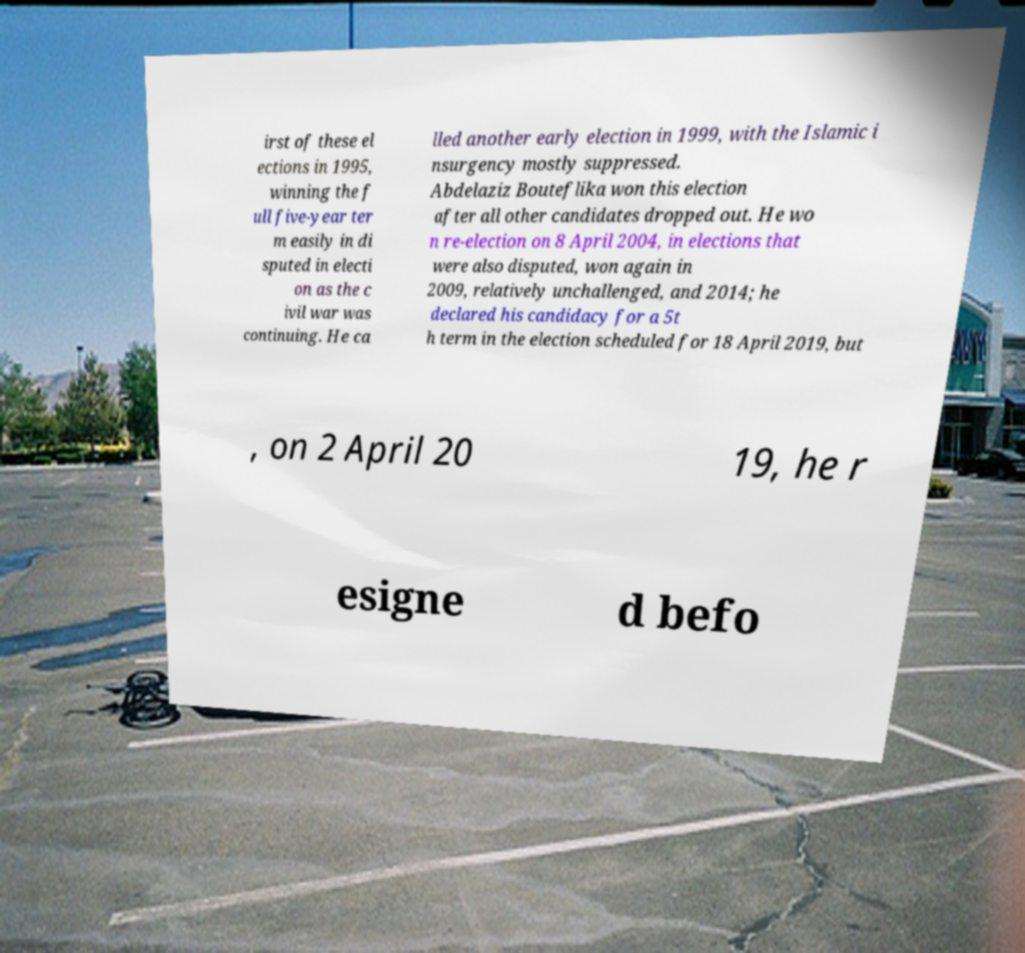Please read and relay the text visible in this image. What does it say? irst of these el ections in 1995, winning the f ull five-year ter m easily in di sputed in electi on as the c ivil war was continuing. He ca lled another early election in 1999, with the Islamic i nsurgency mostly suppressed. Abdelaziz Bouteflika won this election after all other candidates dropped out. He wo n re-election on 8 April 2004, in elections that were also disputed, won again in 2009, relatively unchallenged, and 2014; he declared his candidacy for a 5t h term in the election scheduled for 18 April 2019, but , on 2 April 20 19, he r esigne d befo 